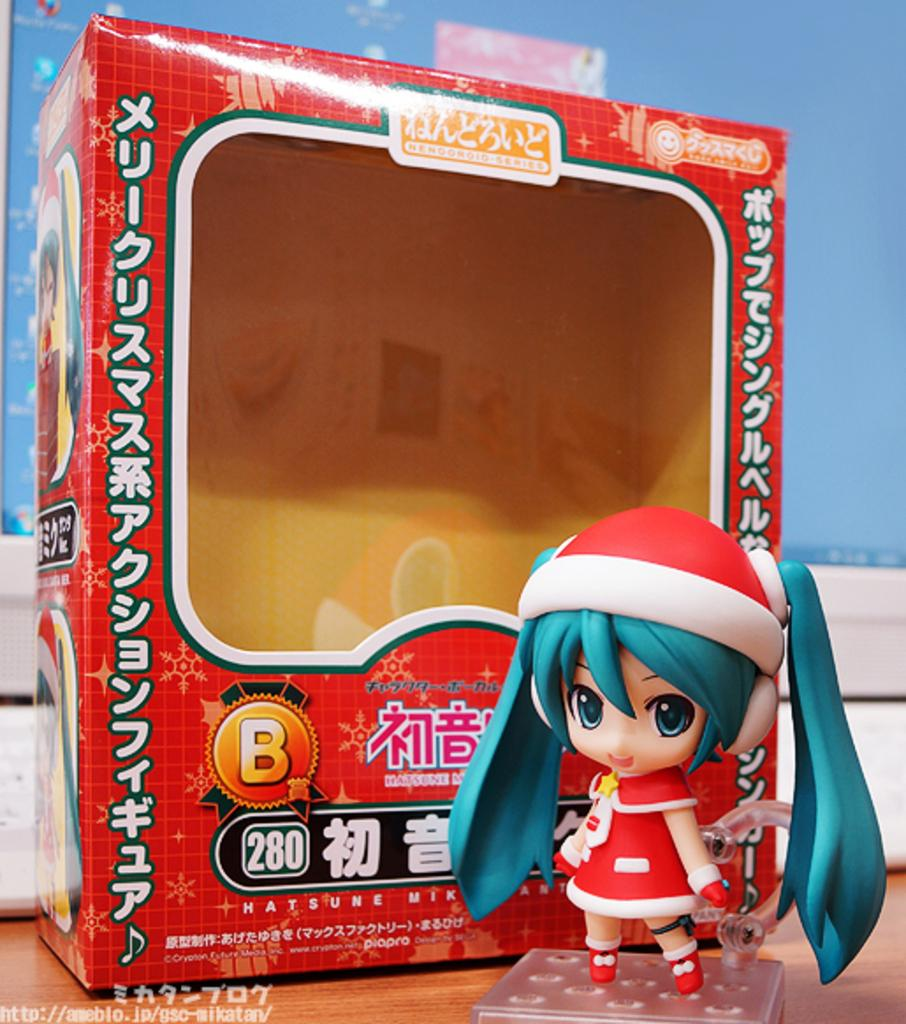What is the main object in the image? There is a doll in the image. What else can be seen in the image besides the doll? There is a box and a wooden surface visible in the image. What is located in the background of the image? There is a monitor in the background of the image. Can you describe the argument between the doll and the desk in the image? There is no desk present in the image, and therefore no argument between the doll and the desk can be observed. 